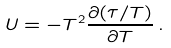Convert formula to latex. <formula><loc_0><loc_0><loc_500><loc_500>U = - T ^ { 2 } \frac { \partial ( \tau / T ) } { \partial T } \, .</formula> 